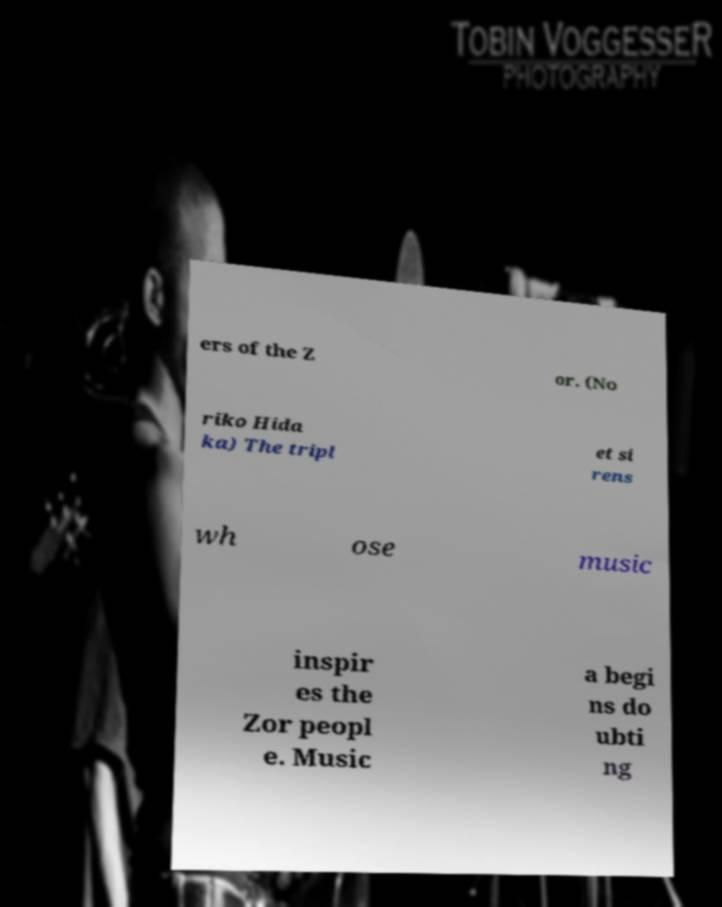Could you assist in decoding the text presented in this image and type it out clearly? ers of the Z or. (No riko Hida ka) The tripl et si rens wh ose music inspir es the Zor peopl e. Music a begi ns do ubti ng 